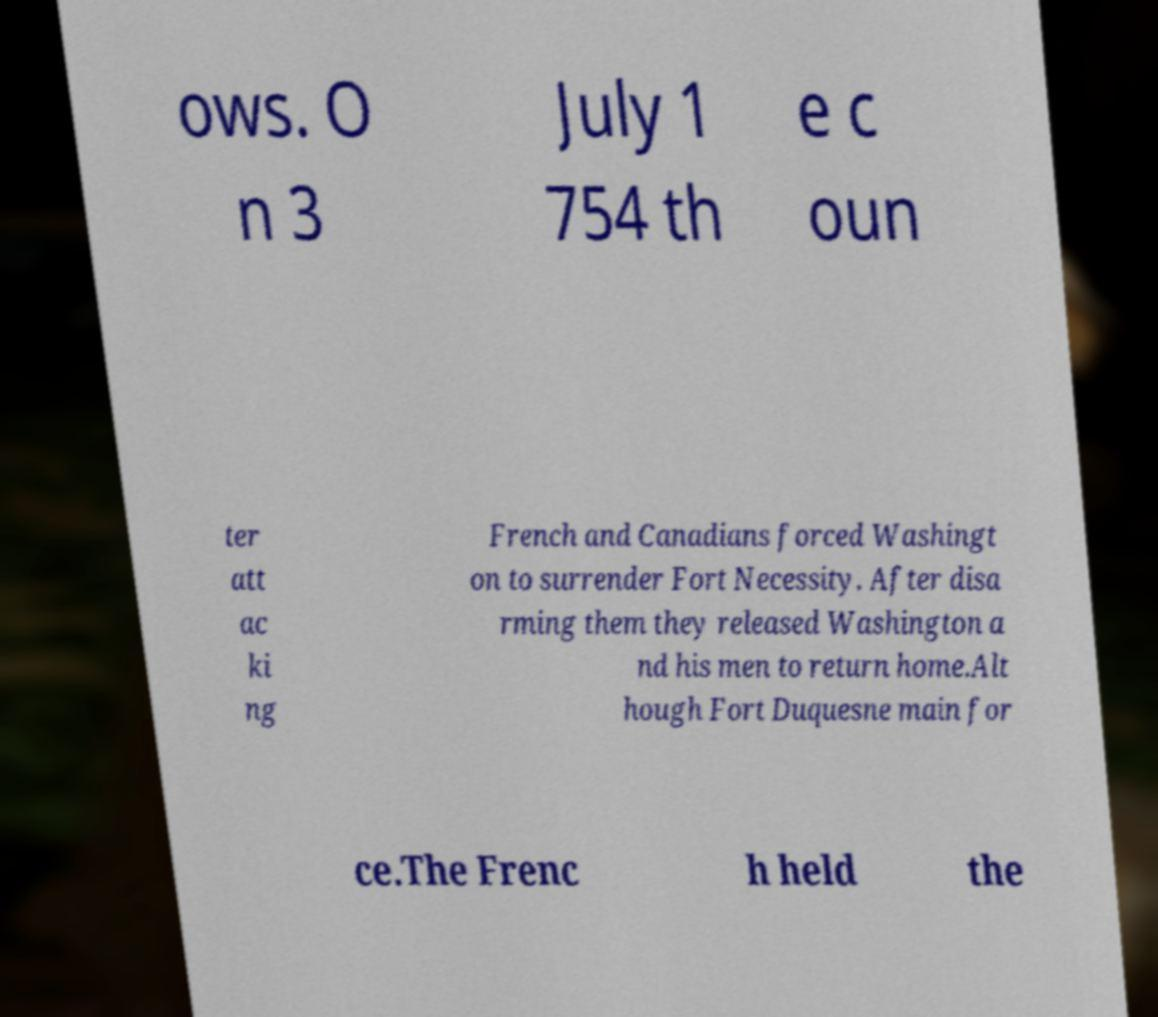I need the written content from this picture converted into text. Can you do that? ows. O n 3 July 1 754 th e c oun ter att ac ki ng French and Canadians forced Washingt on to surrender Fort Necessity. After disa rming them they released Washington a nd his men to return home.Alt hough Fort Duquesne main for ce.The Frenc h held the 